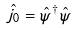Convert formula to latex. <formula><loc_0><loc_0><loc_500><loc_500>\hat { j } _ { 0 } = \hat { \psi } ^ { \dagger } \hat { \psi }</formula> 